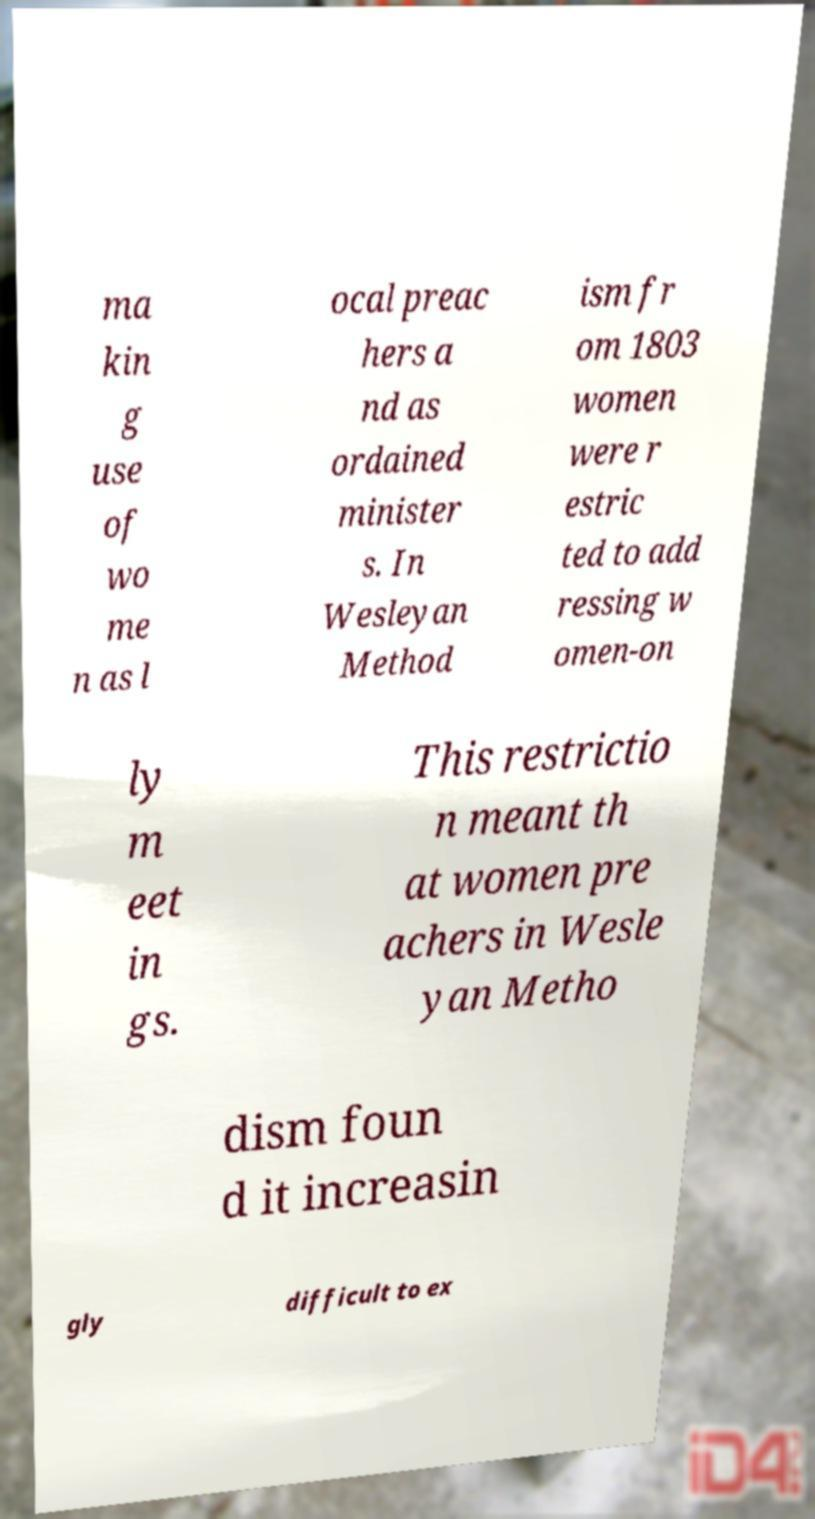Can you accurately transcribe the text from the provided image for me? ma kin g use of wo me n as l ocal preac hers a nd as ordained minister s. In Wesleyan Method ism fr om 1803 women were r estric ted to add ressing w omen-on ly m eet in gs. This restrictio n meant th at women pre achers in Wesle yan Metho dism foun d it increasin gly difficult to ex 